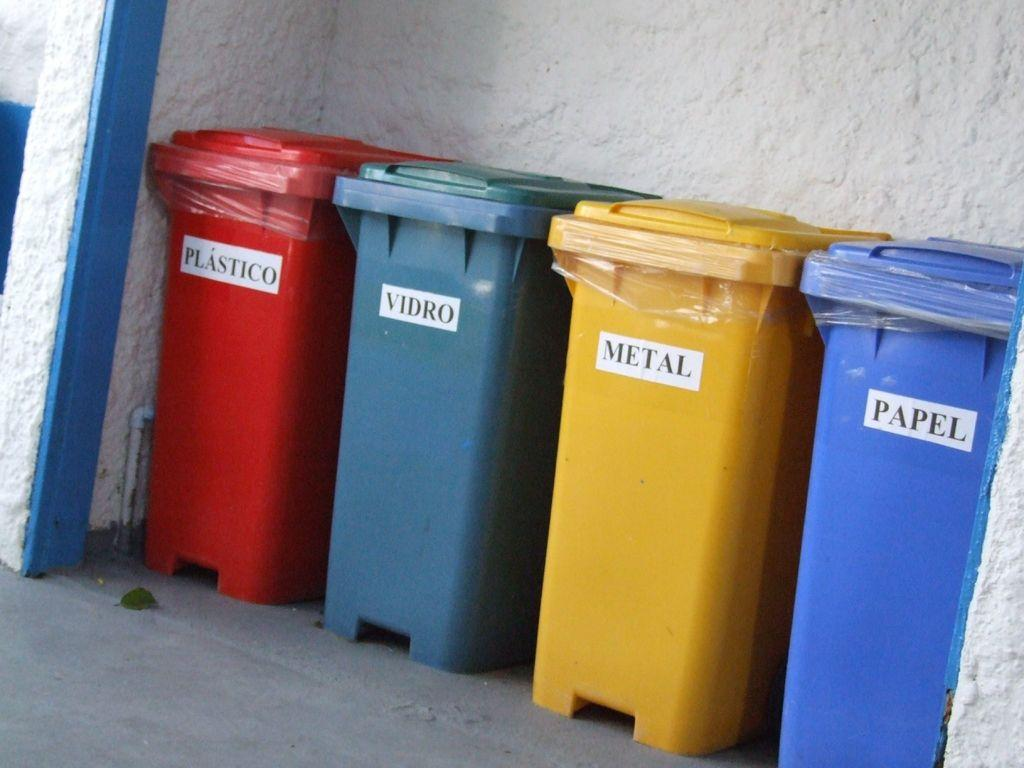<image>
Present a compact description of the photo's key features. Four different colored waste bins are labeled with the yellow one being for metal. 